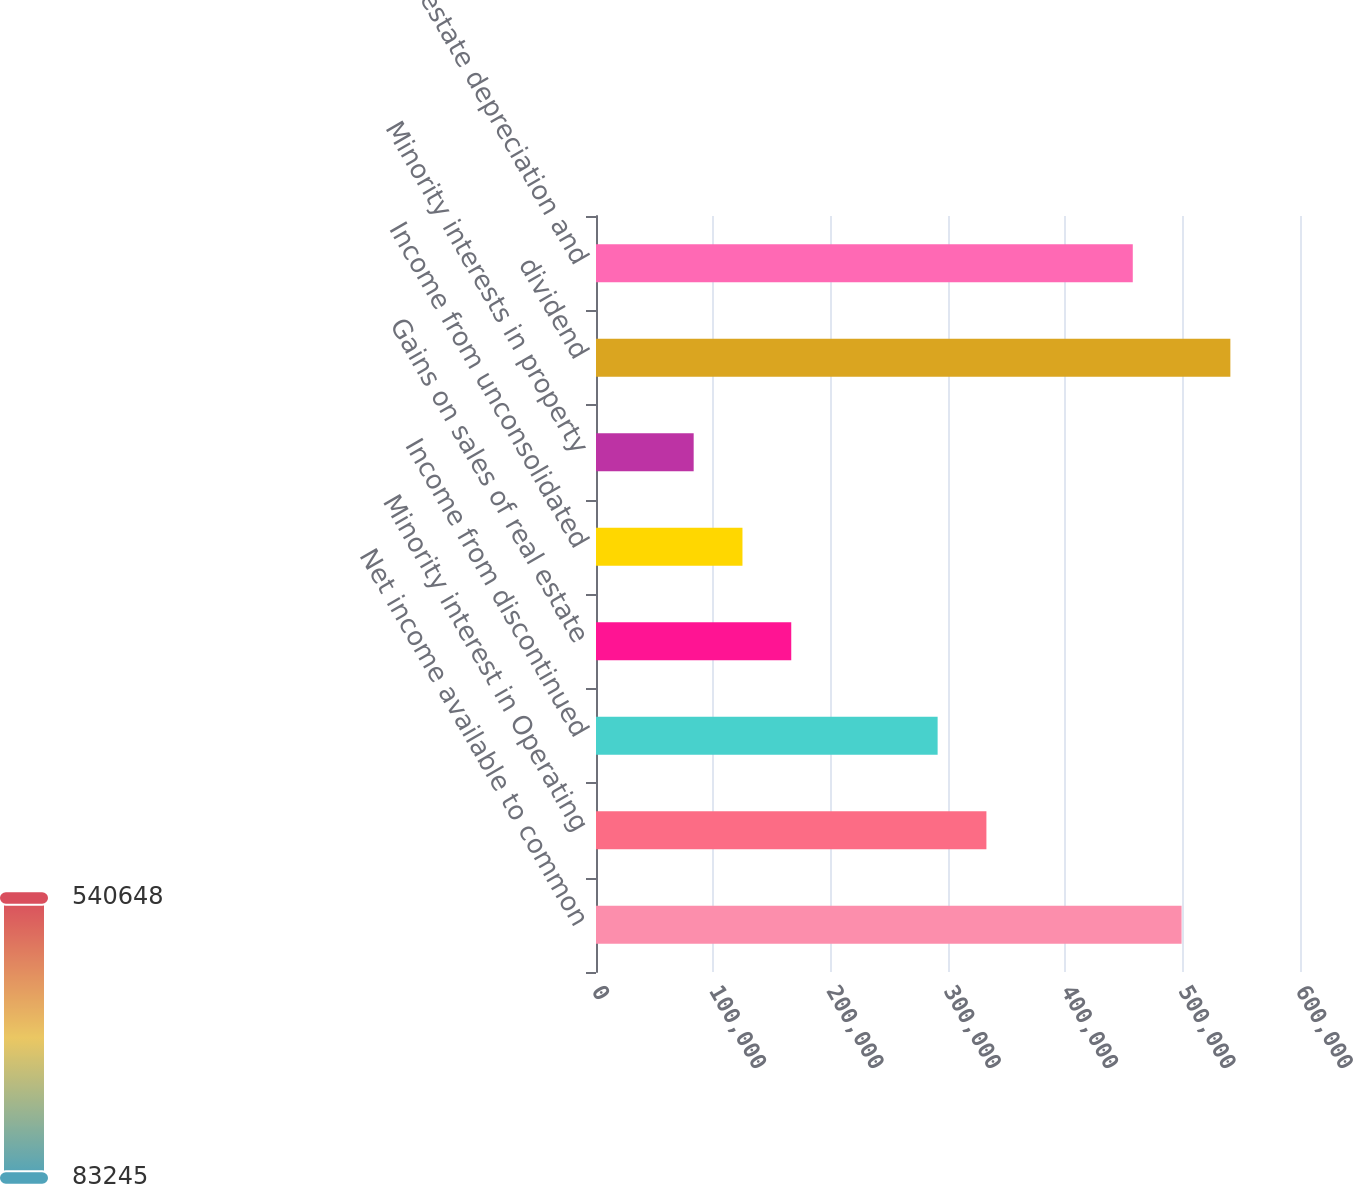Convert chart. <chart><loc_0><loc_0><loc_500><loc_500><bar_chart><fcel>Net income available to common<fcel>Minority interest in Operating<fcel>Income from discontinued<fcel>Gains on sales of real estate<fcel>Income from unconsolidated<fcel>Minority interests in property<fcel>dividend<fcel>Real estate depreciation and<nl><fcel>499066<fcel>332738<fcel>291156<fcel>166410<fcel>124827<fcel>83245.4<fcel>540648<fcel>457484<nl></chart> 